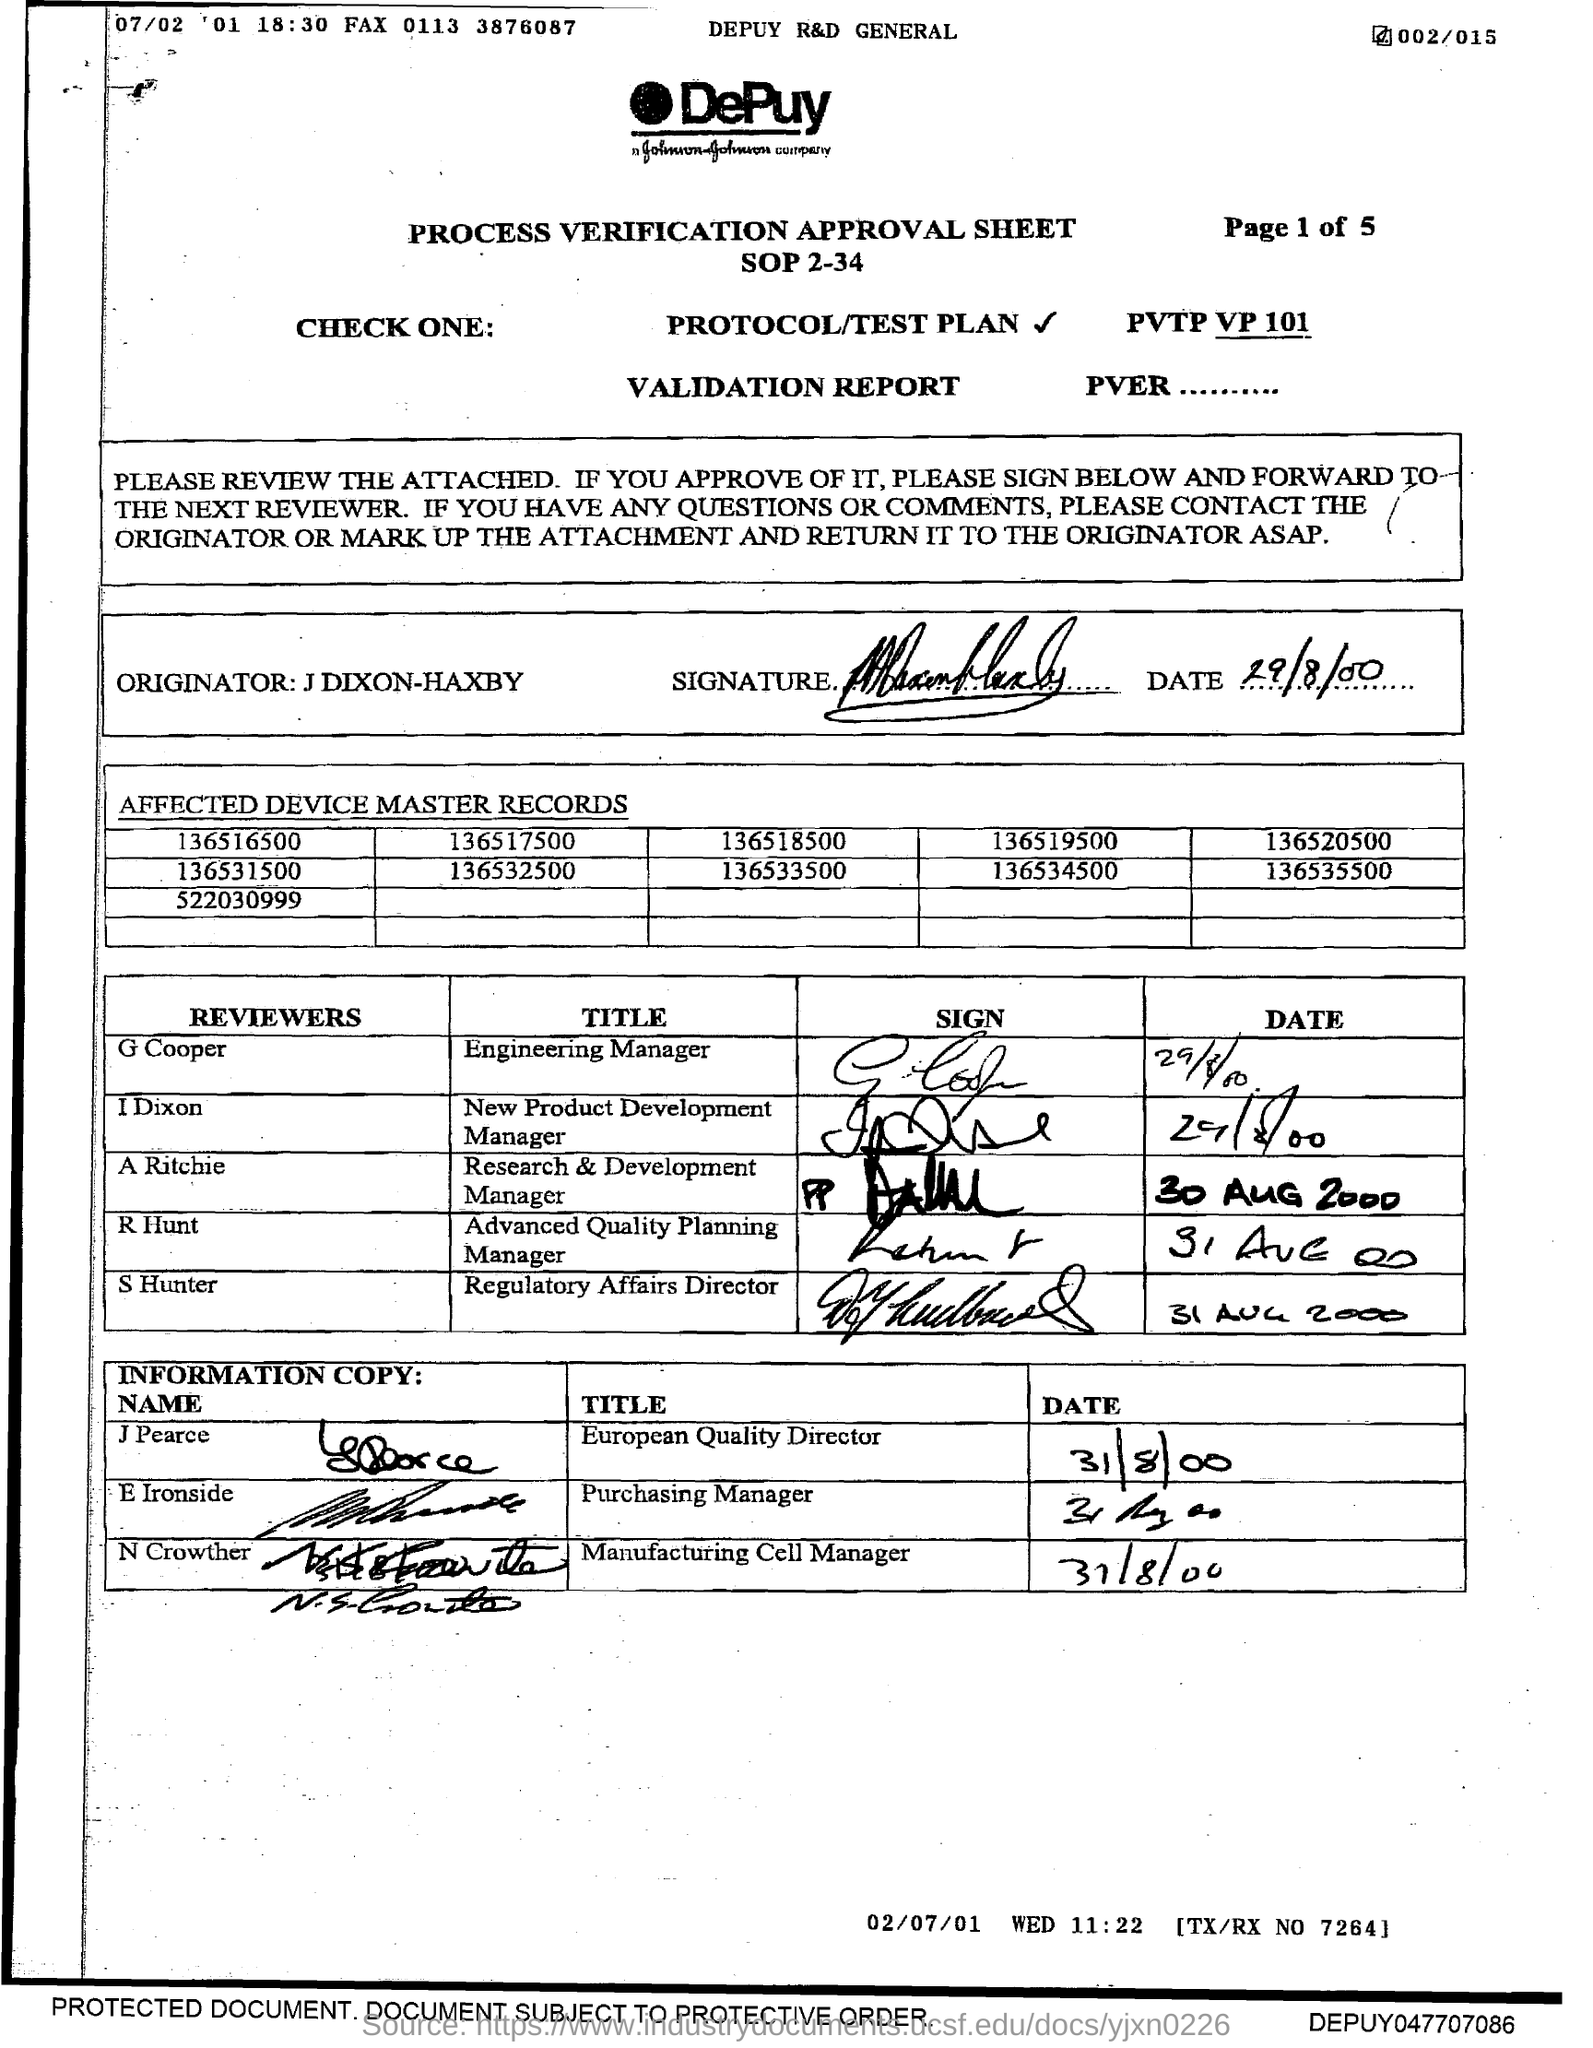Outline some significant characteristics in this image. The title 'Advanced Quality Planning Manager' has been reviewed by R Hunt. The title of Engineering Manager has been reviewed by G Cooper. The title of Regulatory Affairs Director has been reviewed by S Hunter. 